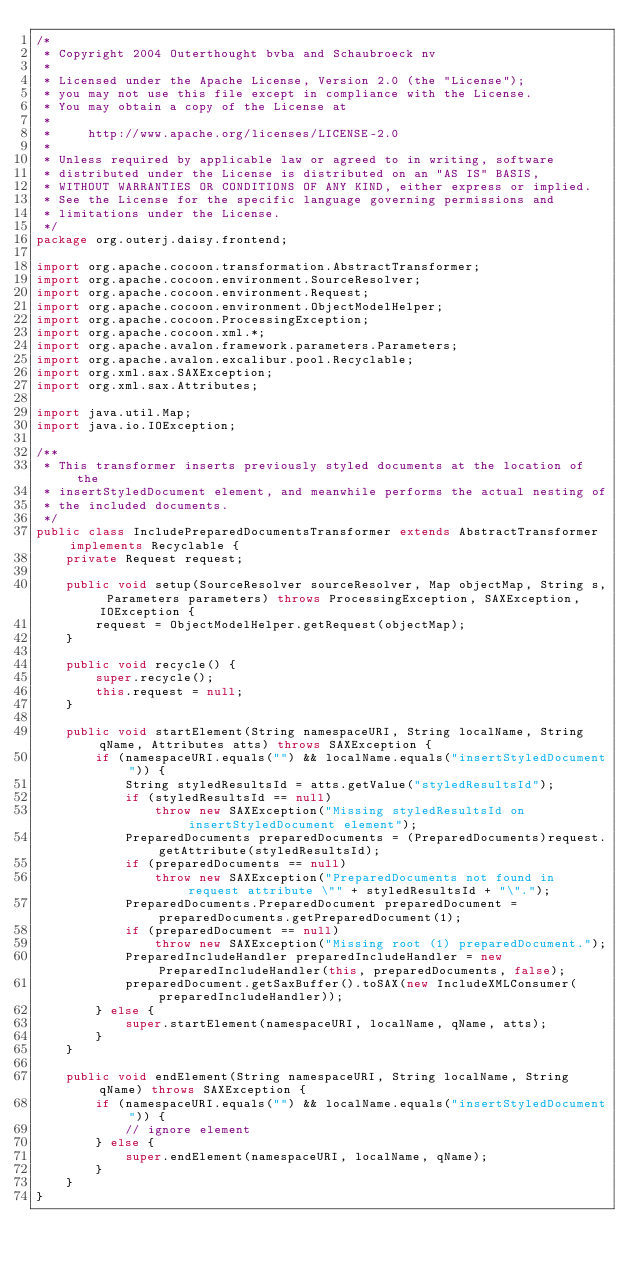Convert code to text. <code><loc_0><loc_0><loc_500><loc_500><_Java_>/*
 * Copyright 2004 Outerthought bvba and Schaubroeck nv
 *
 * Licensed under the Apache License, Version 2.0 (the "License");
 * you may not use this file except in compliance with the License.
 * You may obtain a copy of the License at
 *
 *     http://www.apache.org/licenses/LICENSE-2.0
 *
 * Unless required by applicable law or agreed to in writing, software
 * distributed under the License is distributed on an "AS IS" BASIS,
 * WITHOUT WARRANTIES OR CONDITIONS OF ANY KIND, either express or implied.
 * See the License for the specific language governing permissions and
 * limitations under the License.
 */
package org.outerj.daisy.frontend;

import org.apache.cocoon.transformation.AbstractTransformer;
import org.apache.cocoon.environment.SourceResolver;
import org.apache.cocoon.environment.Request;
import org.apache.cocoon.environment.ObjectModelHelper;
import org.apache.cocoon.ProcessingException;
import org.apache.cocoon.xml.*;
import org.apache.avalon.framework.parameters.Parameters;
import org.apache.avalon.excalibur.pool.Recyclable;
import org.xml.sax.SAXException;
import org.xml.sax.Attributes;

import java.util.Map;
import java.io.IOException;

/**
 * This transformer inserts previously styled documents at the location of the
 * insertStyledDocument element, and meanwhile performs the actual nesting of
 * the included documents.
 */
public class IncludePreparedDocumentsTransformer extends AbstractTransformer implements Recyclable {
    private Request request;

    public void setup(SourceResolver sourceResolver, Map objectMap, String s, Parameters parameters) throws ProcessingException, SAXException, IOException {
        request = ObjectModelHelper.getRequest(objectMap);
    }

    public void recycle() {
        super.recycle();
        this.request = null;
    }

    public void startElement(String namespaceURI, String localName, String qName, Attributes atts) throws SAXException {
        if (namespaceURI.equals("") && localName.equals("insertStyledDocument")) {
            String styledResultsId = atts.getValue("styledResultsId");
            if (styledResultsId == null)
                throw new SAXException("Missing styledResultsId on insertStyledDocument element");
            PreparedDocuments preparedDocuments = (PreparedDocuments)request.getAttribute(styledResultsId);
            if (preparedDocuments == null)
                throw new SAXException("PreparedDocuments not found in request attribute \"" + styledResultsId + "\".");
            PreparedDocuments.PreparedDocument preparedDocument = preparedDocuments.getPreparedDocument(1);
            if (preparedDocument == null)
                throw new SAXException("Missing root (1) preparedDocument.");
            PreparedIncludeHandler preparedIncludeHandler = new PreparedIncludeHandler(this, preparedDocuments, false);
            preparedDocument.getSaxBuffer().toSAX(new IncludeXMLConsumer(preparedIncludeHandler));
        } else {
            super.startElement(namespaceURI, localName, qName, atts);
        }
    }

    public void endElement(String namespaceURI, String localName, String qName) throws SAXException {
        if (namespaceURI.equals("") && localName.equals("insertStyledDocument")) {
            // ignore element
        } else {
            super.endElement(namespaceURI, localName, qName);
        }
    }
}
</code> 